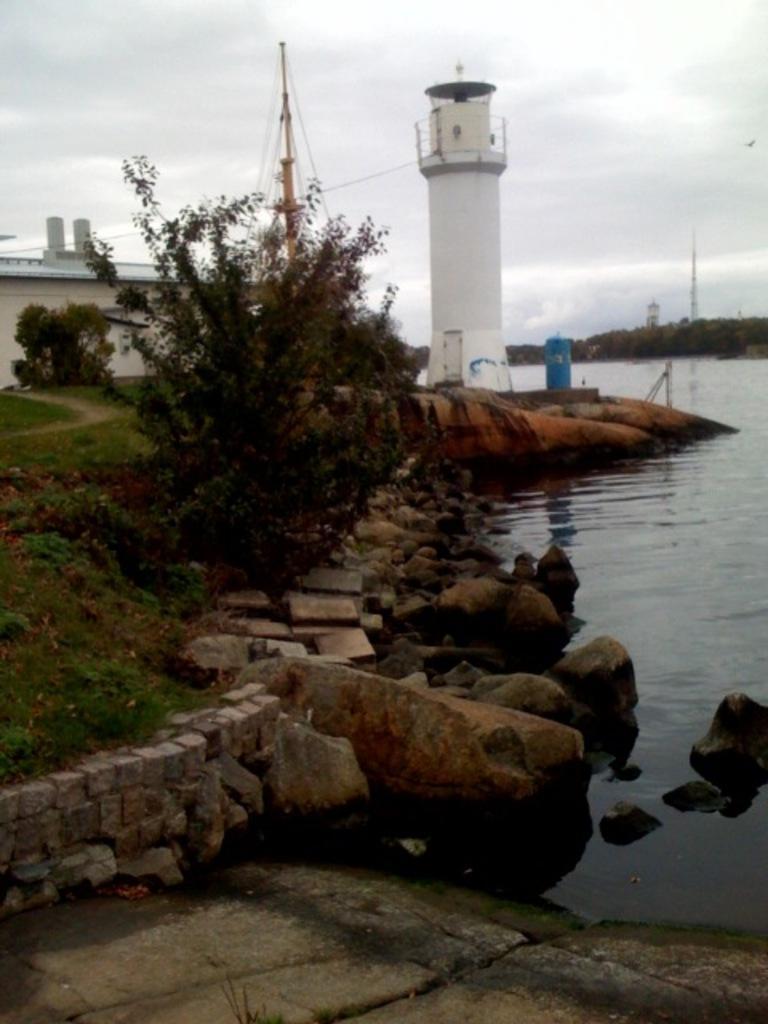How would you summarize this image in a sentence or two? In front of the image there are rocks, grass, plants, a factory and a metal structure, in front of the metal structure, there is a lighthouse, a lake, on the other side of the lake there are trees and two towers, at the top of the image there are clouds in the sky. 